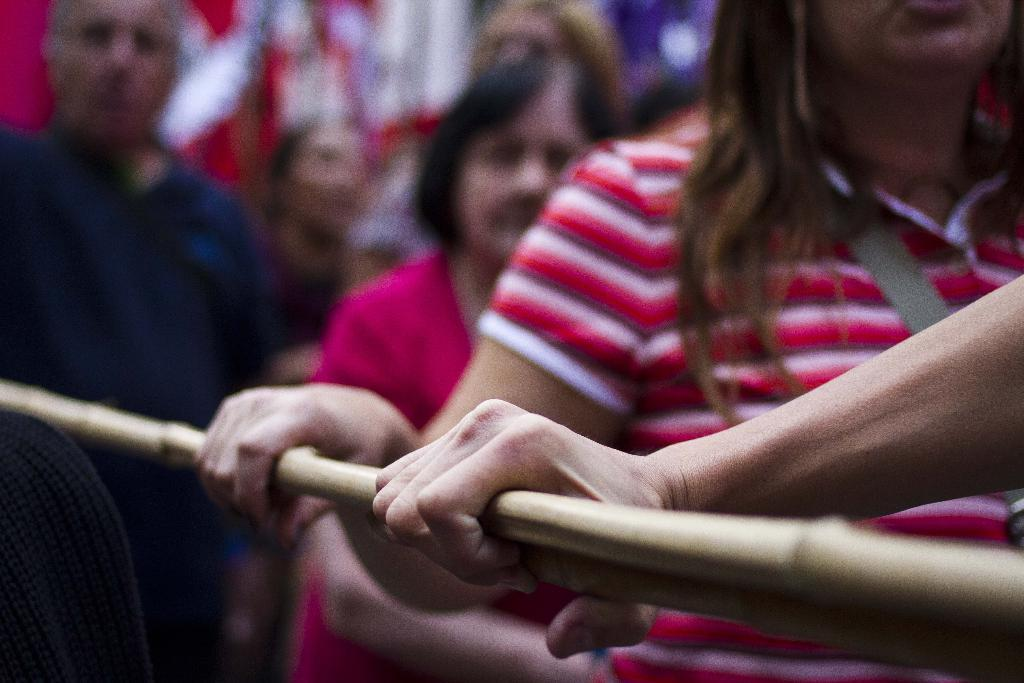What can be seen in the image? There are people in the image. What are the people holding in their hands? The people are holding sticks. Can you describe the background of the image? The background of the image is blurry. What type of sheet is covering the downtown area in the image? There is no sheet or downtown area present in the image. 